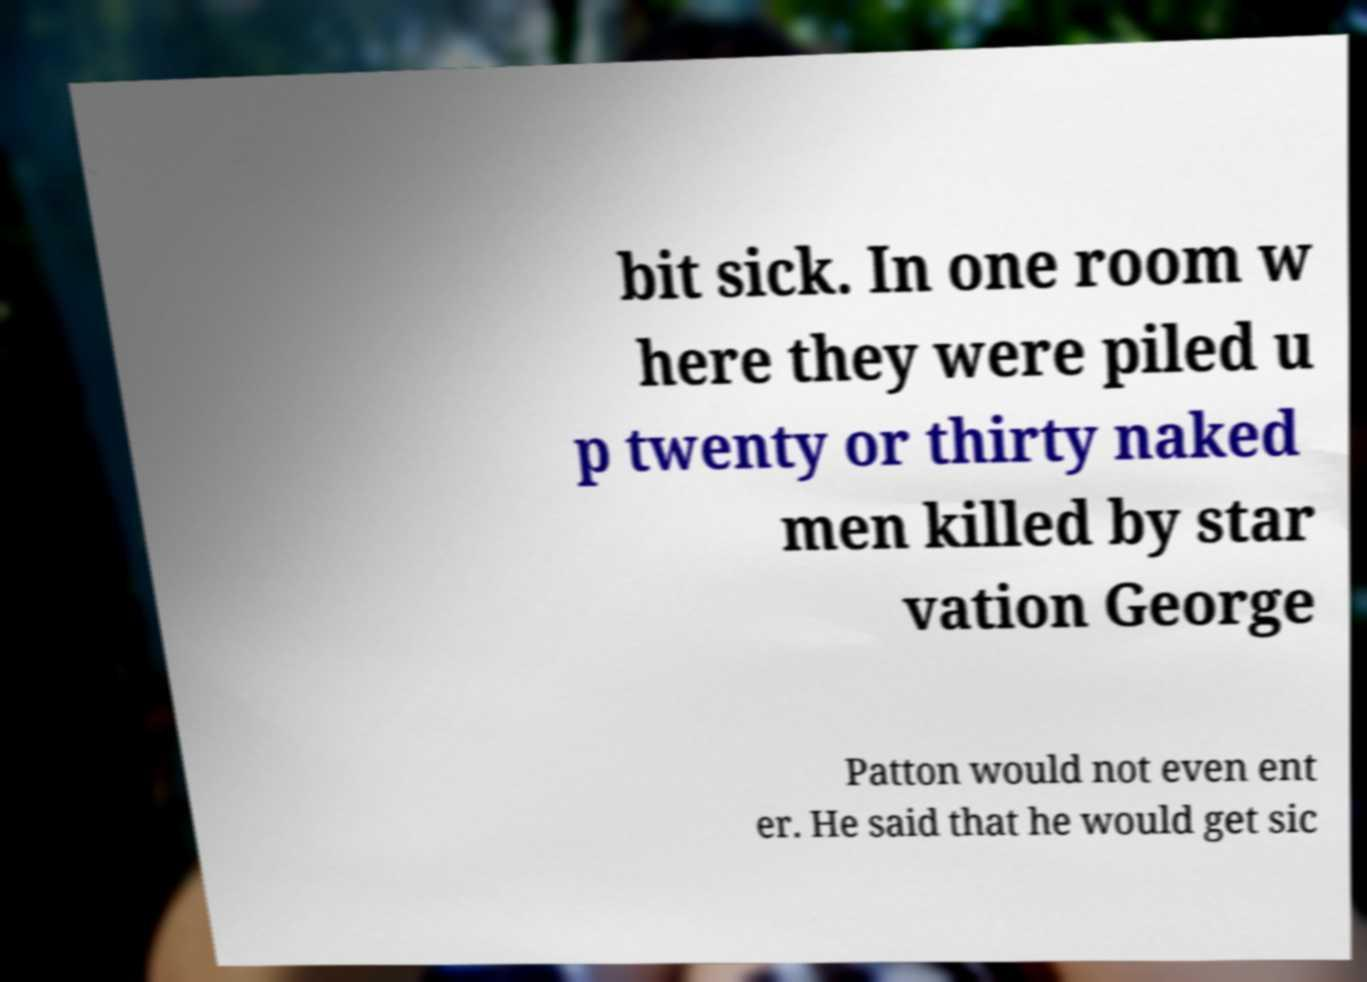I need the written content from this picture converted into text. Can you do that? bit sick. In one room w here they were piled u p twenty or thirty naked men killed by star vation George Patton would not even ent er. He said that he would get sic 